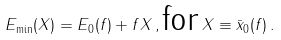<formula> <loc_0><loc_0><loc_500><loc_500>E _ { \min } ( X ) = E _ { 0 } ( f ) + f X \, , \text {for} \, X \equiv \bar { x } _ { 0 } ( f ) \, .</formula> 